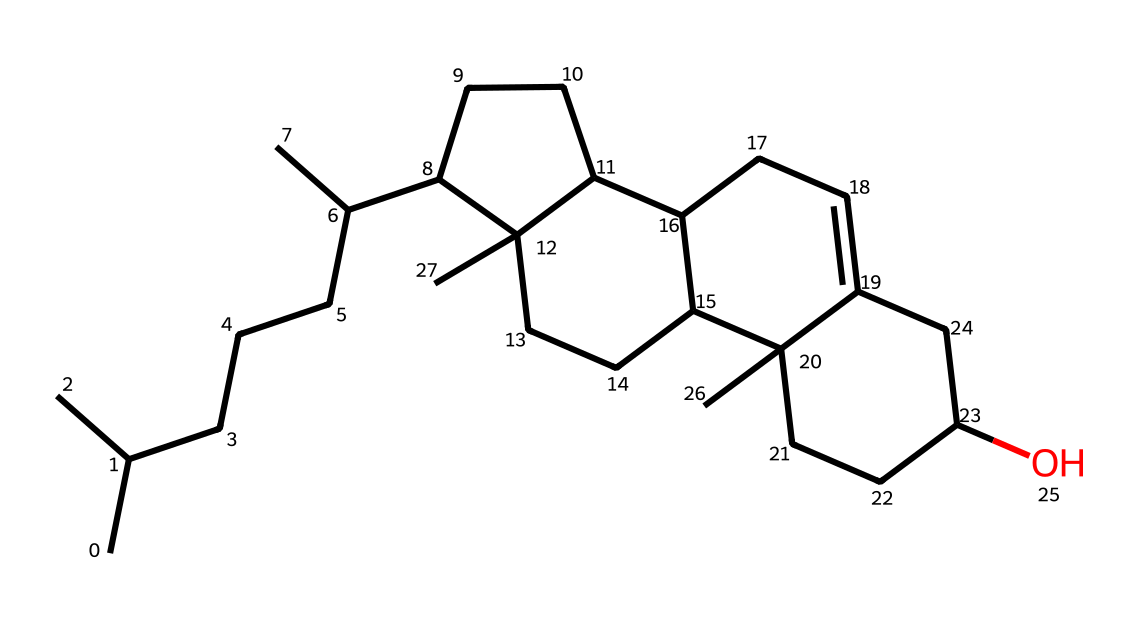How many carbon atoms are present in the chemical structure of lanolin? By analyzing the SMILES representation, we can count the number of 'C' characters, which represent carbon atoms. In this case, there are 27 carbon atoms in total.
Answer: 27 What type of chemical compound is lanolin classified as? Considering its composition, lanolin is derived from natural sources and has lubricating properties, making it a lipid or fatty substance.
Answer: lipid What is the primary function of lanolin as a lubricant? Lanolin's major function is to provide moisture and lubrication, which is essential for skin protection and conditioning.
Answer: moisture Does lanolin contain any functional groups? By examining the structure, we can identify a hydroxyl group (-OH) that indicates the presence of alcohols, confirming that lanolin does have functional groups.
Answer: yes Which part of the structure contributes to lanolin's hydrophobic properties? The long hydrocarbon chains contribute significantly to the hydrophobic characteristics, as they minimize interaction with water.
Answer: hydrocarbon chains What is the total number of oxygen atoms in the chemical structure? We can identify the number of 'O' in the SMILES representation; it appears only once, indicating there is one oxygen atom present in lanolin.
Answer: 1 How does the cyclic structure in lanolin influence its viscosity? The presence of cyclic structures often increases the viscosity of compounds due to the spatial arrangement and interactions among the rings, contributing to its thick texture as a lubricant.
Answer: increases viscosity 